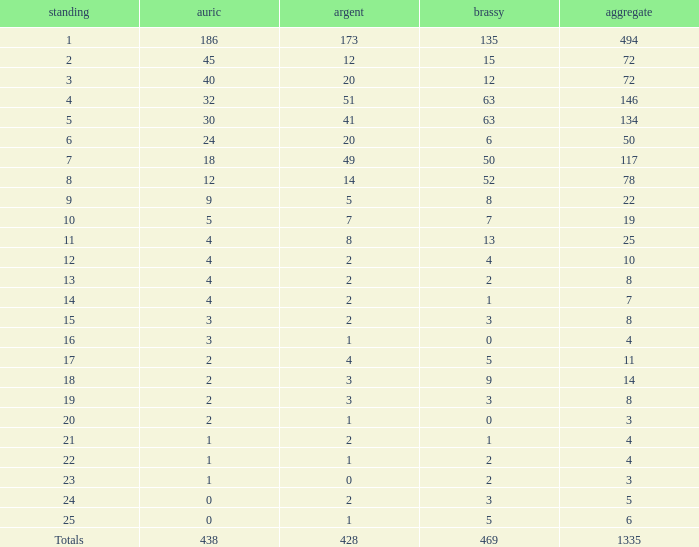What is the average number of gold medals when the total was 1335 medals, with more than 469 bronzes and more than 14 silvers? None. 